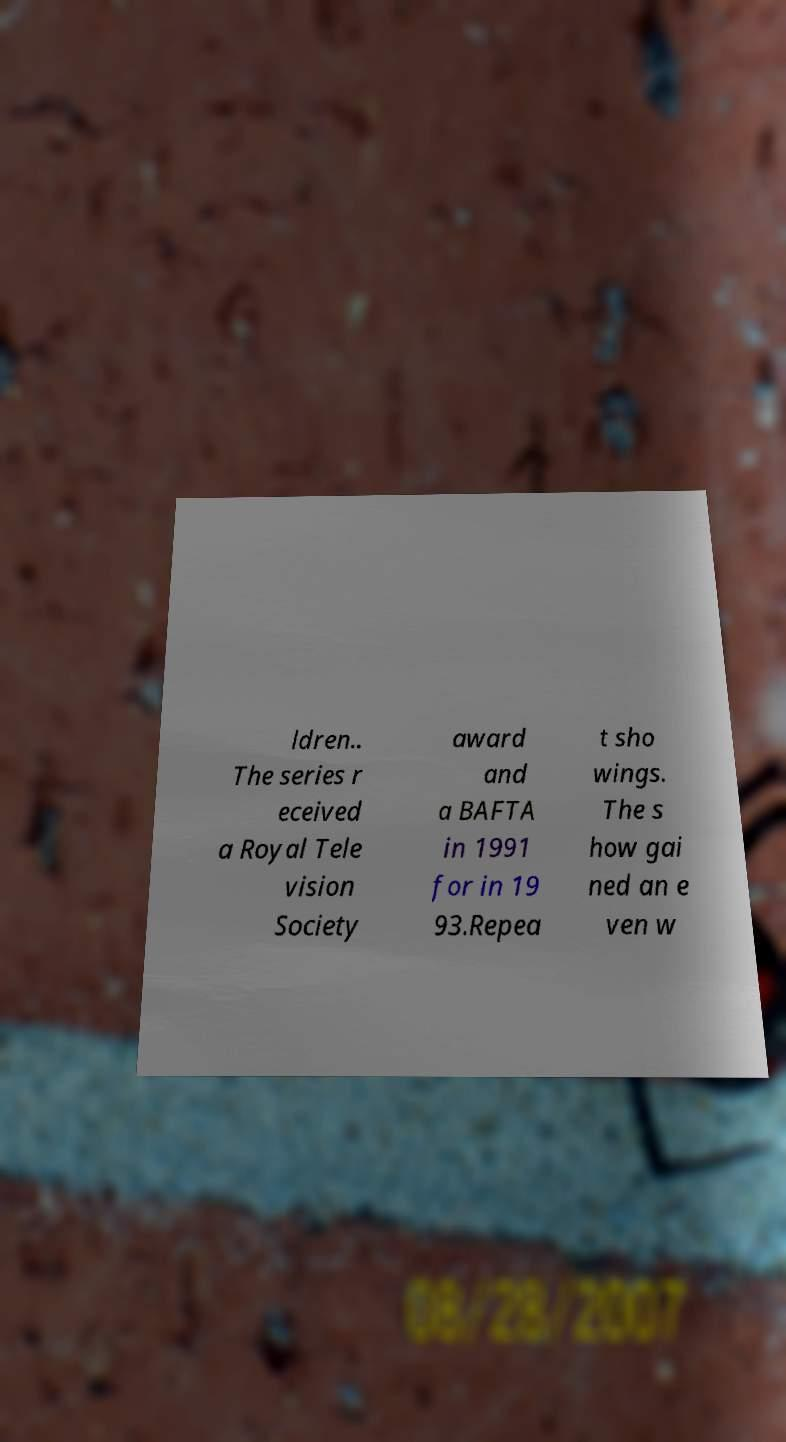Could you extract and type out the text from this image? ldren.. The series r eceived a Royal Tele vision Society award and a BAFTA in 1991 for in 19 93.Repea t sho wings. The s how gai ned an e ven w 